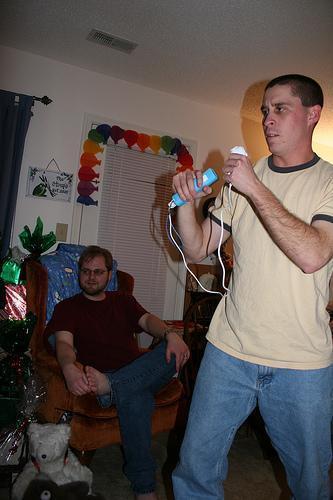How many people are there?
Give a very brief answer. 2. How many people are wearing glasses?
Give a very brief answer. 1. 